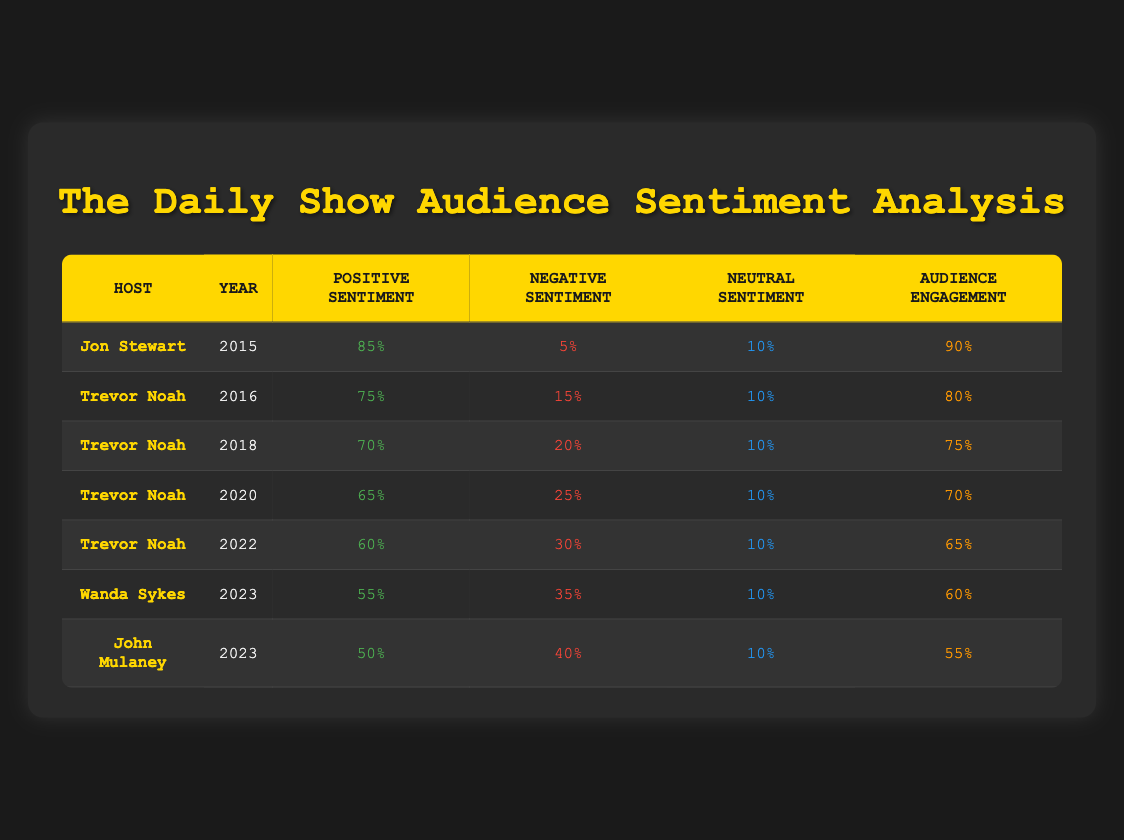What was the positive sentiment for Jon Stewart in 2015? The table shows that Jon Stewart had a positive sentiment of 85% in 2015.
Answer: 85% Which host had the highest audience engagement? By checking the Engagement column, Jon Stewart has the highest audience engagement at 90%.
Answer: 90% What is the average negative sentiment across Trevor Noah's years? Trevor Noah's negative sentiments are 15%, 20%, 25%, 30%. To find the average, sum them: 15 + 20 + 25 + 30 = 90, then divide by the number of observations (4): 90/4 = 22.5%.
Answer: 22.5% Did the negative sentiment increase or decrease during Trevor Noah's tenure from 2016 to 2022? The negative sentiment increased from 15% in 2016 to 30% in 2022. Therefore, it is an increase.
Answer: Yes Which host had the lowest positive sentiment, and what was that percentage? Looking at the Positive Sentiment column, John Mulaney had the lowest value at 50%.
Answer: John Mulaney, 50% What was the change in audience engagement from Jon Stewart to Wanda Sykes? Jon Stewart's engagement was 90% and Wanda Sykes' was 60%. The change is 90 - 60 = 30%.
Answer: 30% decrease Was 2023 a year of declining positive sentiment for "The Daily Show" compared to 2018? In 2018, Trevor Noah had a positive sentiment of 70%, while in 2023 both Wanda Sykes and John Mulaney had positive sentiments of 55% and 50% respectively. Thus, both are lower than 70%.
Answer: Yes What is the trend in audience engagement from 2016 to 2023? The engagement values are 80% in 2016, decreasing to 60% in 2023. This shows a downward trend.
Answer: Downward trend Calculate the median neutral sentiment across all hosts. The neutral sentiment is consistently 10% across all years. Therefore, the median is 10%.
Answer: 10% 